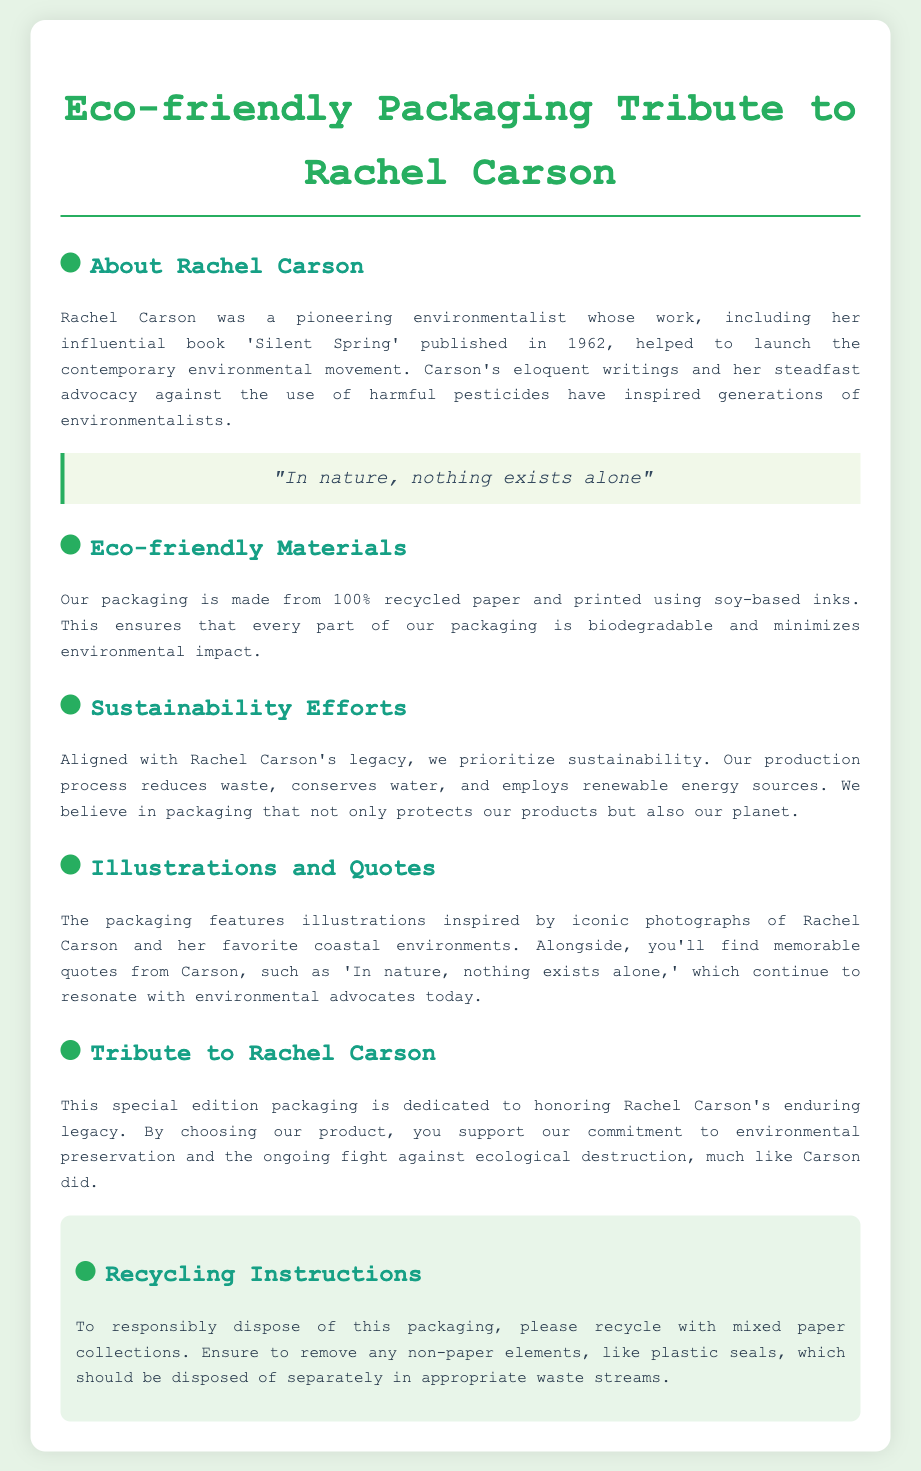what is the name of the environmentalist featured on the packaging? The document mentions Rachel Carson as the pioneering environmentalist featured on the packaging.
Answer: Rachel Carson what year was 'Silent Spring' published? The document states that 'Silent Spring' was published in 1962.
Answer: 1962 what materials is the packaging made from? The document specifies that the packaging is made from 100% recycled paper.
Answer: 100% recycled paper what type of inks are used for printing? According to the document, the packaging is printed using soy-based inks.
Answer: soy-based inks what does the packaging honor? The packaging is dedicated to honoring Rachel Carson's enduring legacy.
Answer: Rachel Carson's enduring legacy what should be removed before recycling the packaging? The document advises to remove any non-paper elements before recycling, specifically mentioning plastic seals.
Answer: plastic seals how does the packaging align with Rachel Carson's legacy? The document indicates that the production process reduces waste and conserves water, thereby prioritizing sustainability, which aligns with Rachel Carson's values.
Answer: prioritizing sustainability how should the packaging be disposed of? The recycling instructions in the document recommend recycling with mixed paper collections.
Answer: mixed paper collections 